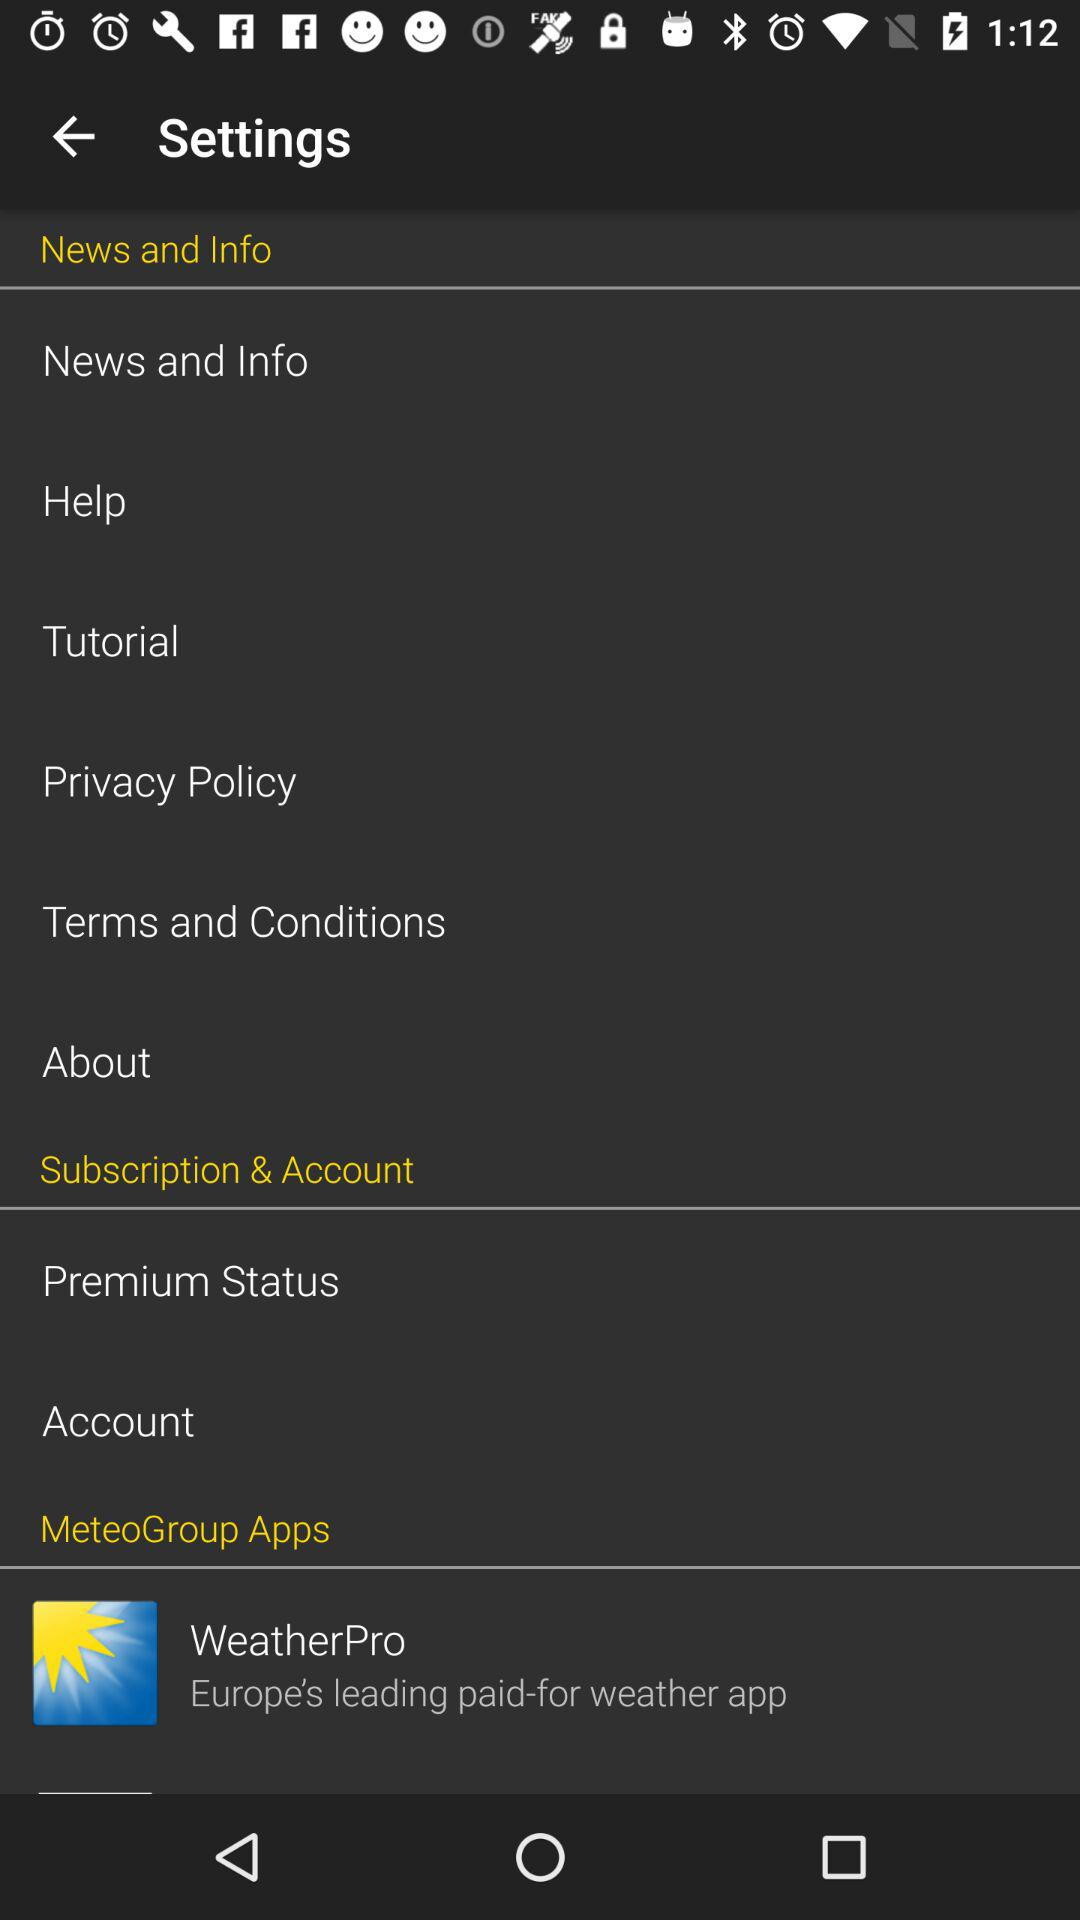Is the application chargeable or free?
When the provided information is insufficient, respond with <no answer>. <no answer> 